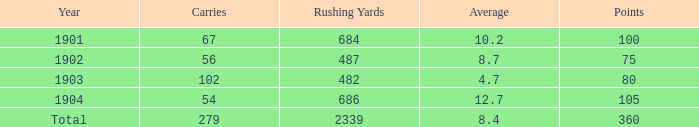7, and less than 487 rushing yards? None. 